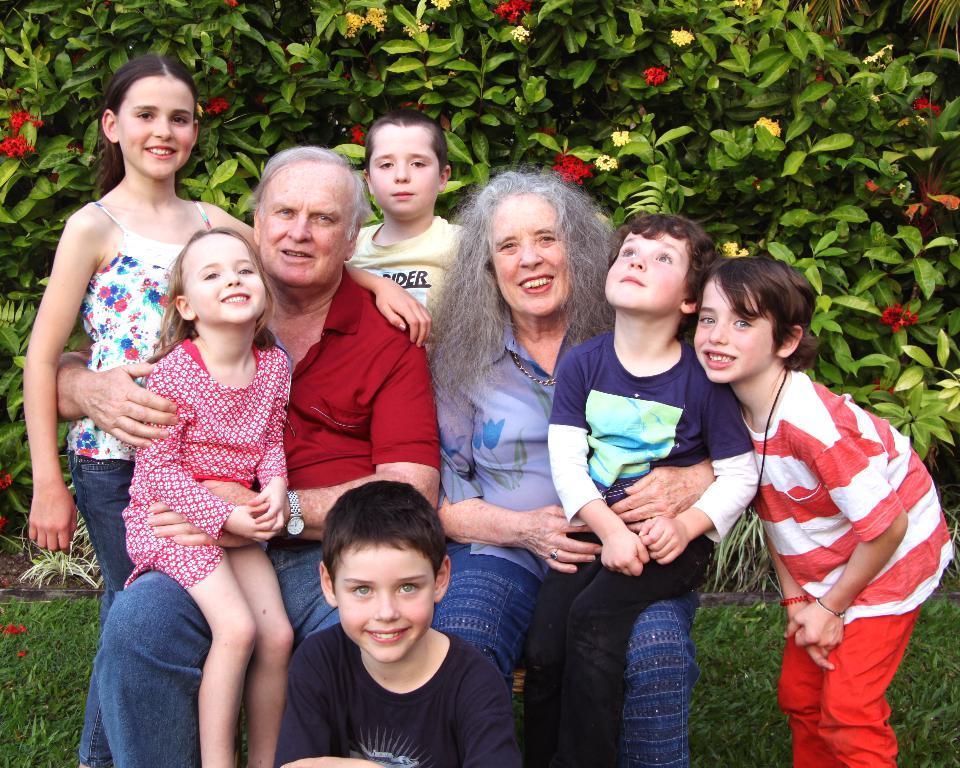Please provide a concise description of this image. There is a man and woman sitting with children. In the background there are plants with flowers. On the ground there are grasses. 